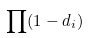Convert formula to latex. <formula><loc_0><loc_0><loc_500><loc_500>\prod ( 1 - d _ { i } )</formula> 